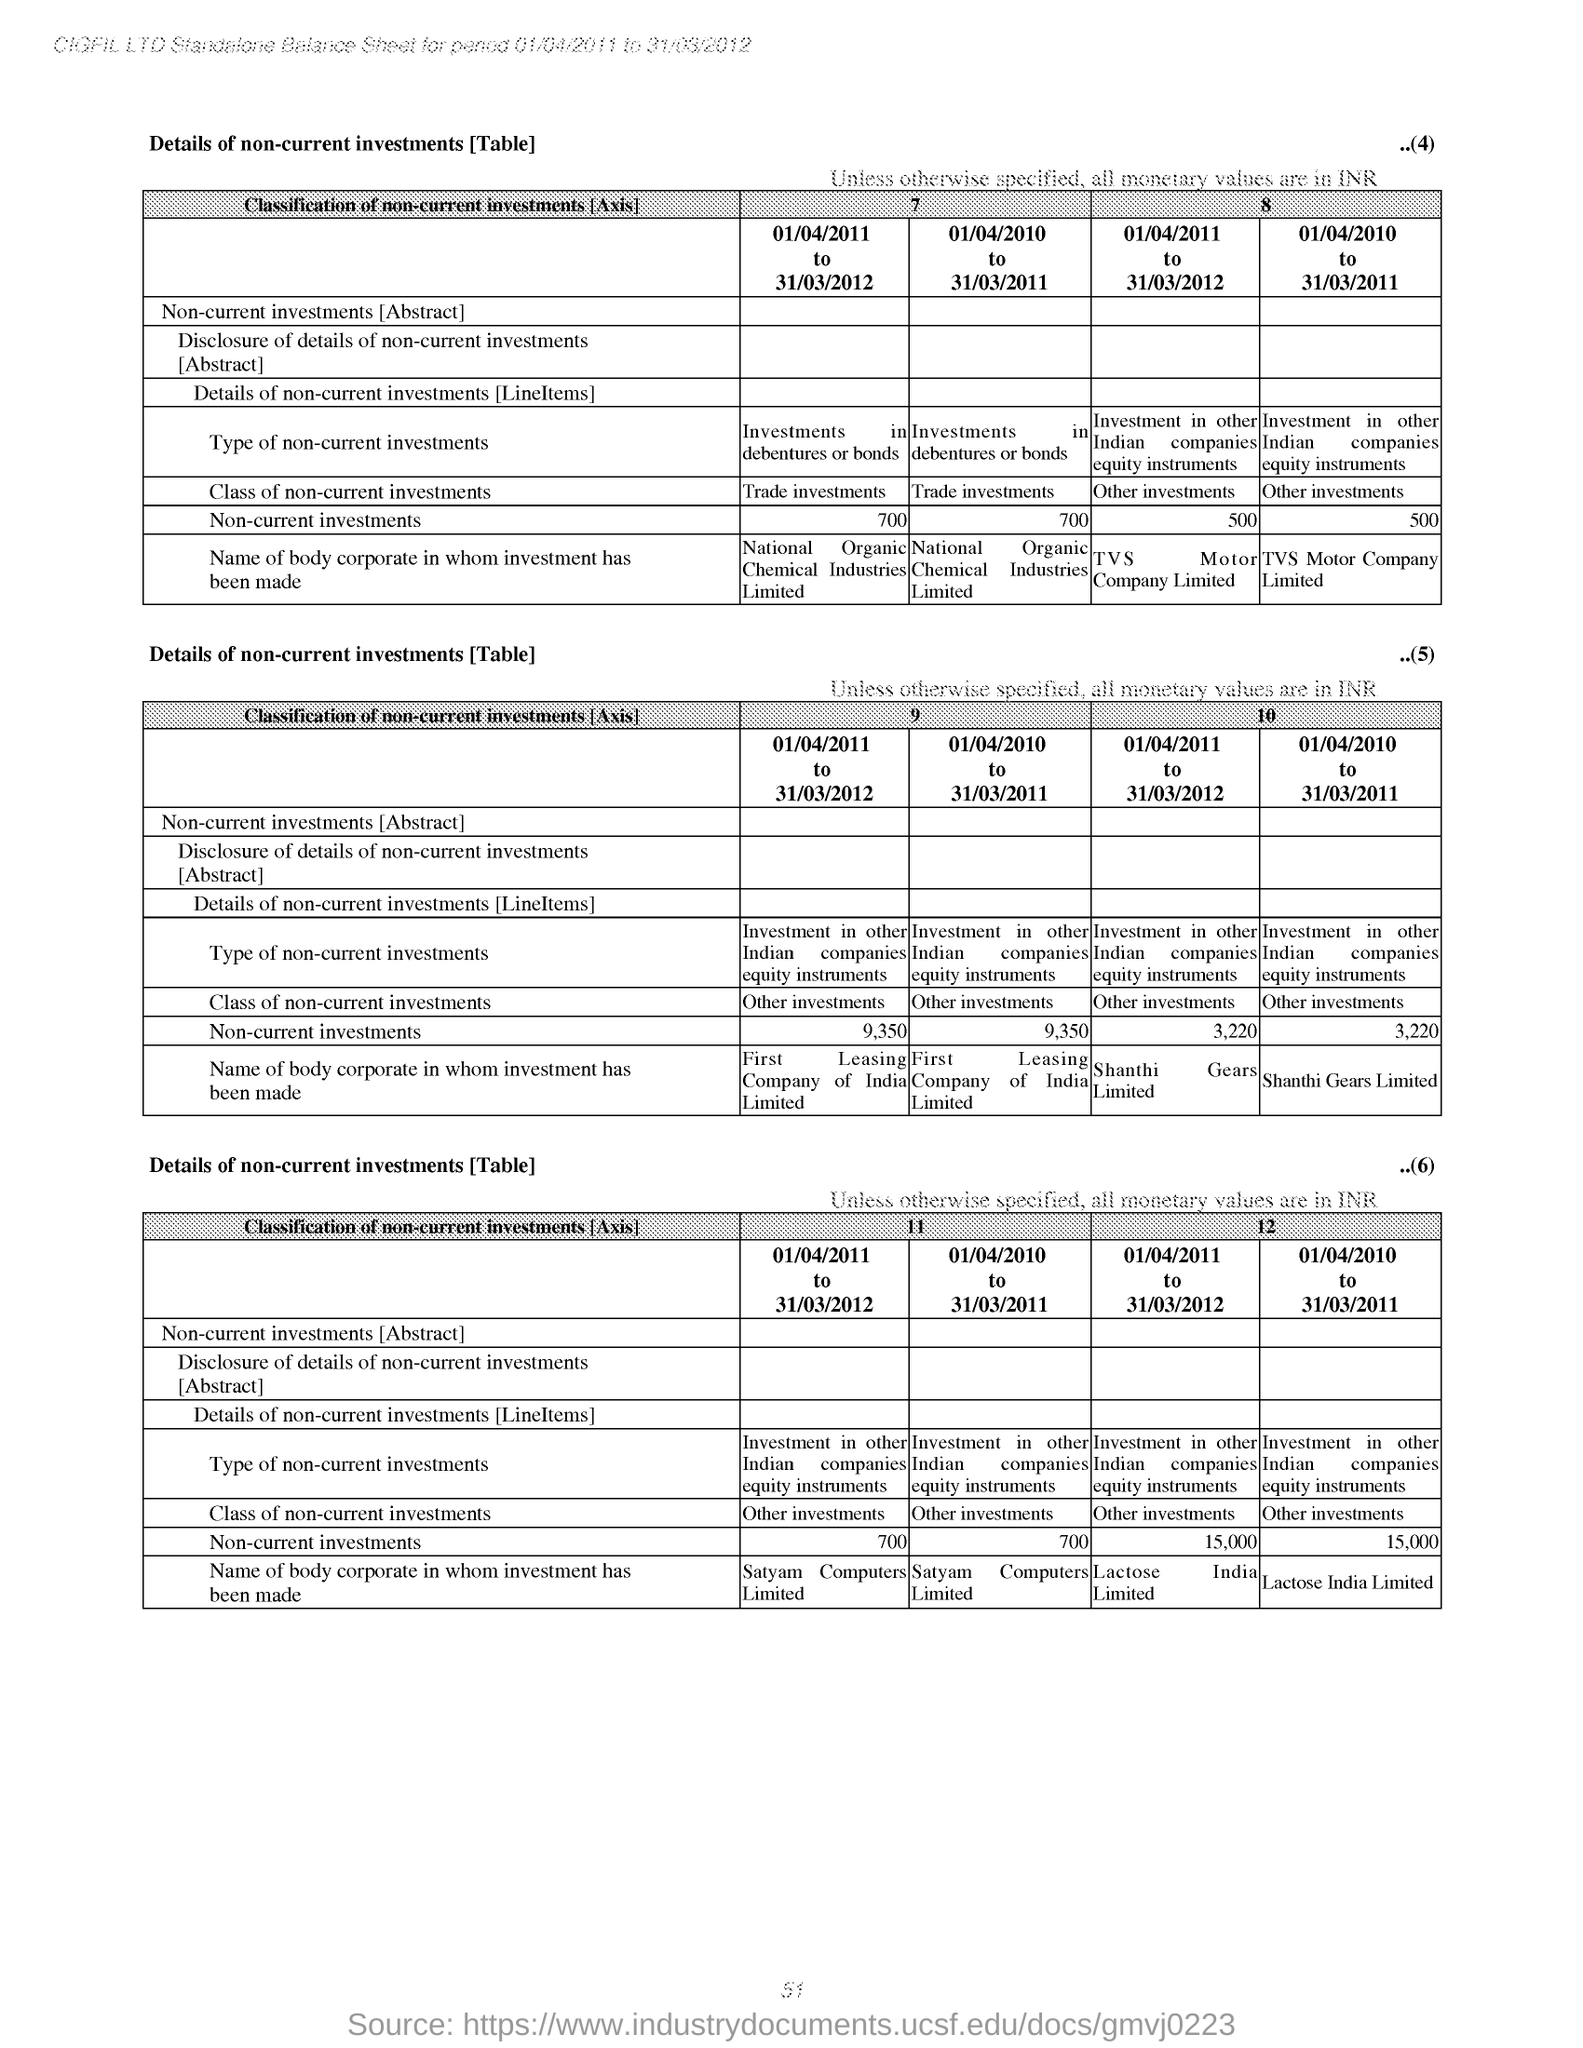How much is the 'Non-current investments' for the period 01/04/2011 to 31/03/2012 under the column '7' of first table?
Give a very brief answer. 700. Name the body corporate in whom investment has been made for the period 01/04/2011 to 31/03/2012 under column '7' of table 1 ?
Give a very brief answer. National Organic Chemical Industries Limited. 